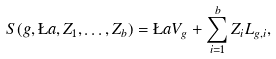Convert formula to latex. <formula><loc_0><loc_0><loc_500><loc_500>S ( g , \L a , Z _ { 1 } , \dots , Z _ { b } ) = \L a V _ { g } + \sum _ { i = 1 } ^ { b } Z _ { i } L _ { g , i } ,</formula> 